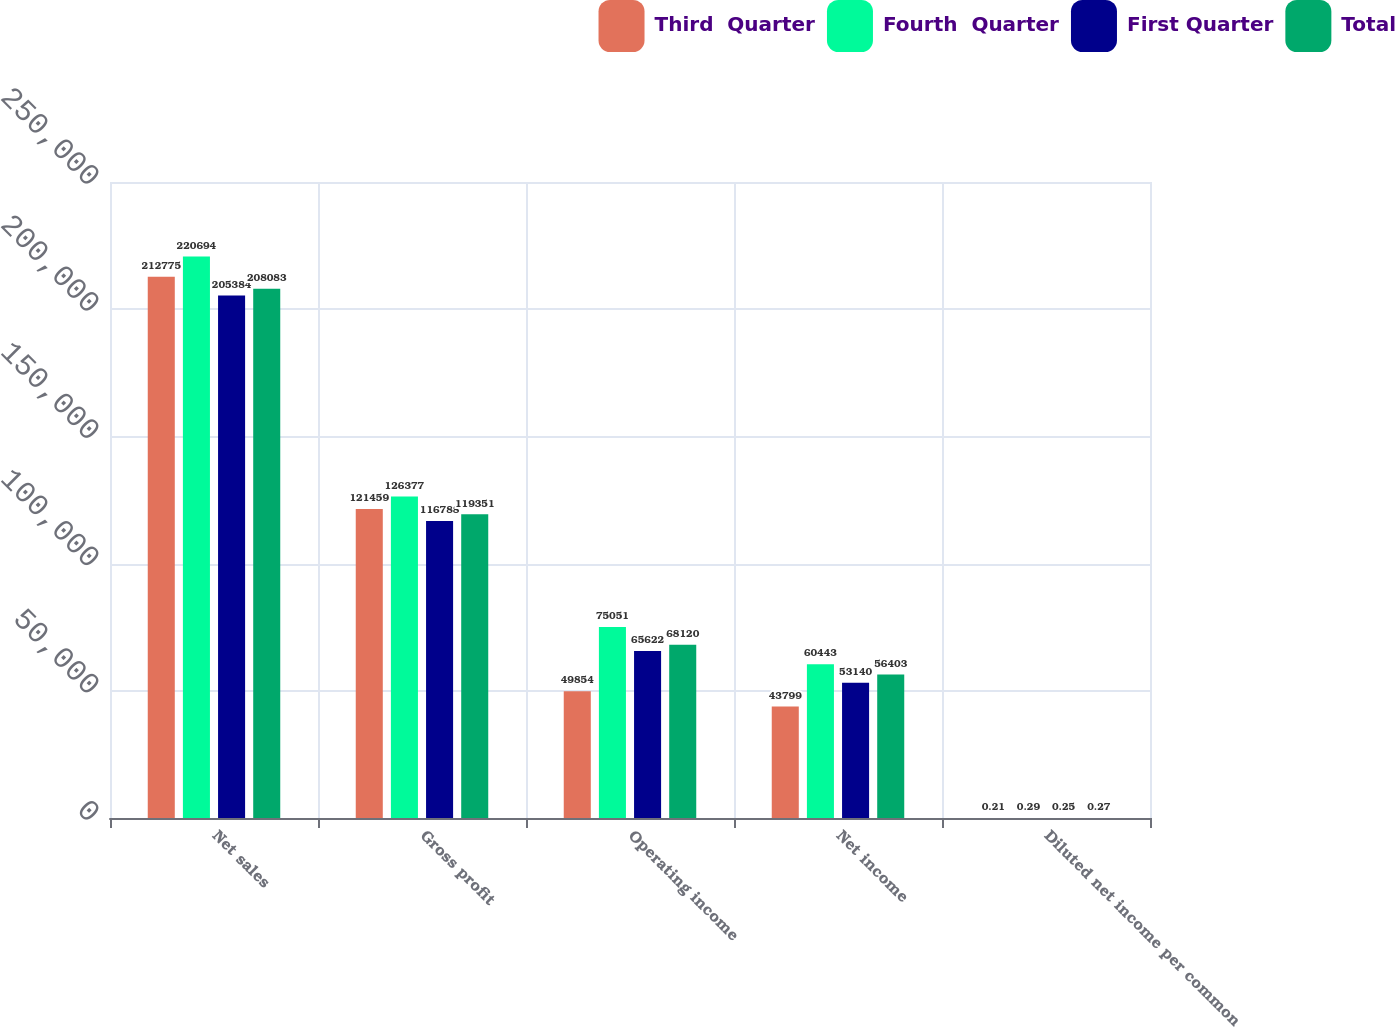Convert chart to OTSL. <chart><loc_0><loc_0><loc_500><loc_500><stacked_bar_chart><ecel><fcel>Net sales<fcel>Gross profit<fcel>Operating income<fcel>Net income<fcel>Diluted net income per common<nl><fcel>Third  Quarter<fcel>212775<fcel>121459<fcel>49854<fcel>43799<fcel>0.21<nl><fcel>Fourth  Quarter<fcel>220694<fcel>126377<fcel>75051<fcel>60443<fcel>0.29<nl><fcel>First Quarter<fcel>205384<fcel>116788<fcel>65622<fcel>53140<fcel>0.25<nl><fcel>Total<fcel>208083<fcel>119351<fcel>68120<fcel>56403<fcel>0.27<nl></chart> 